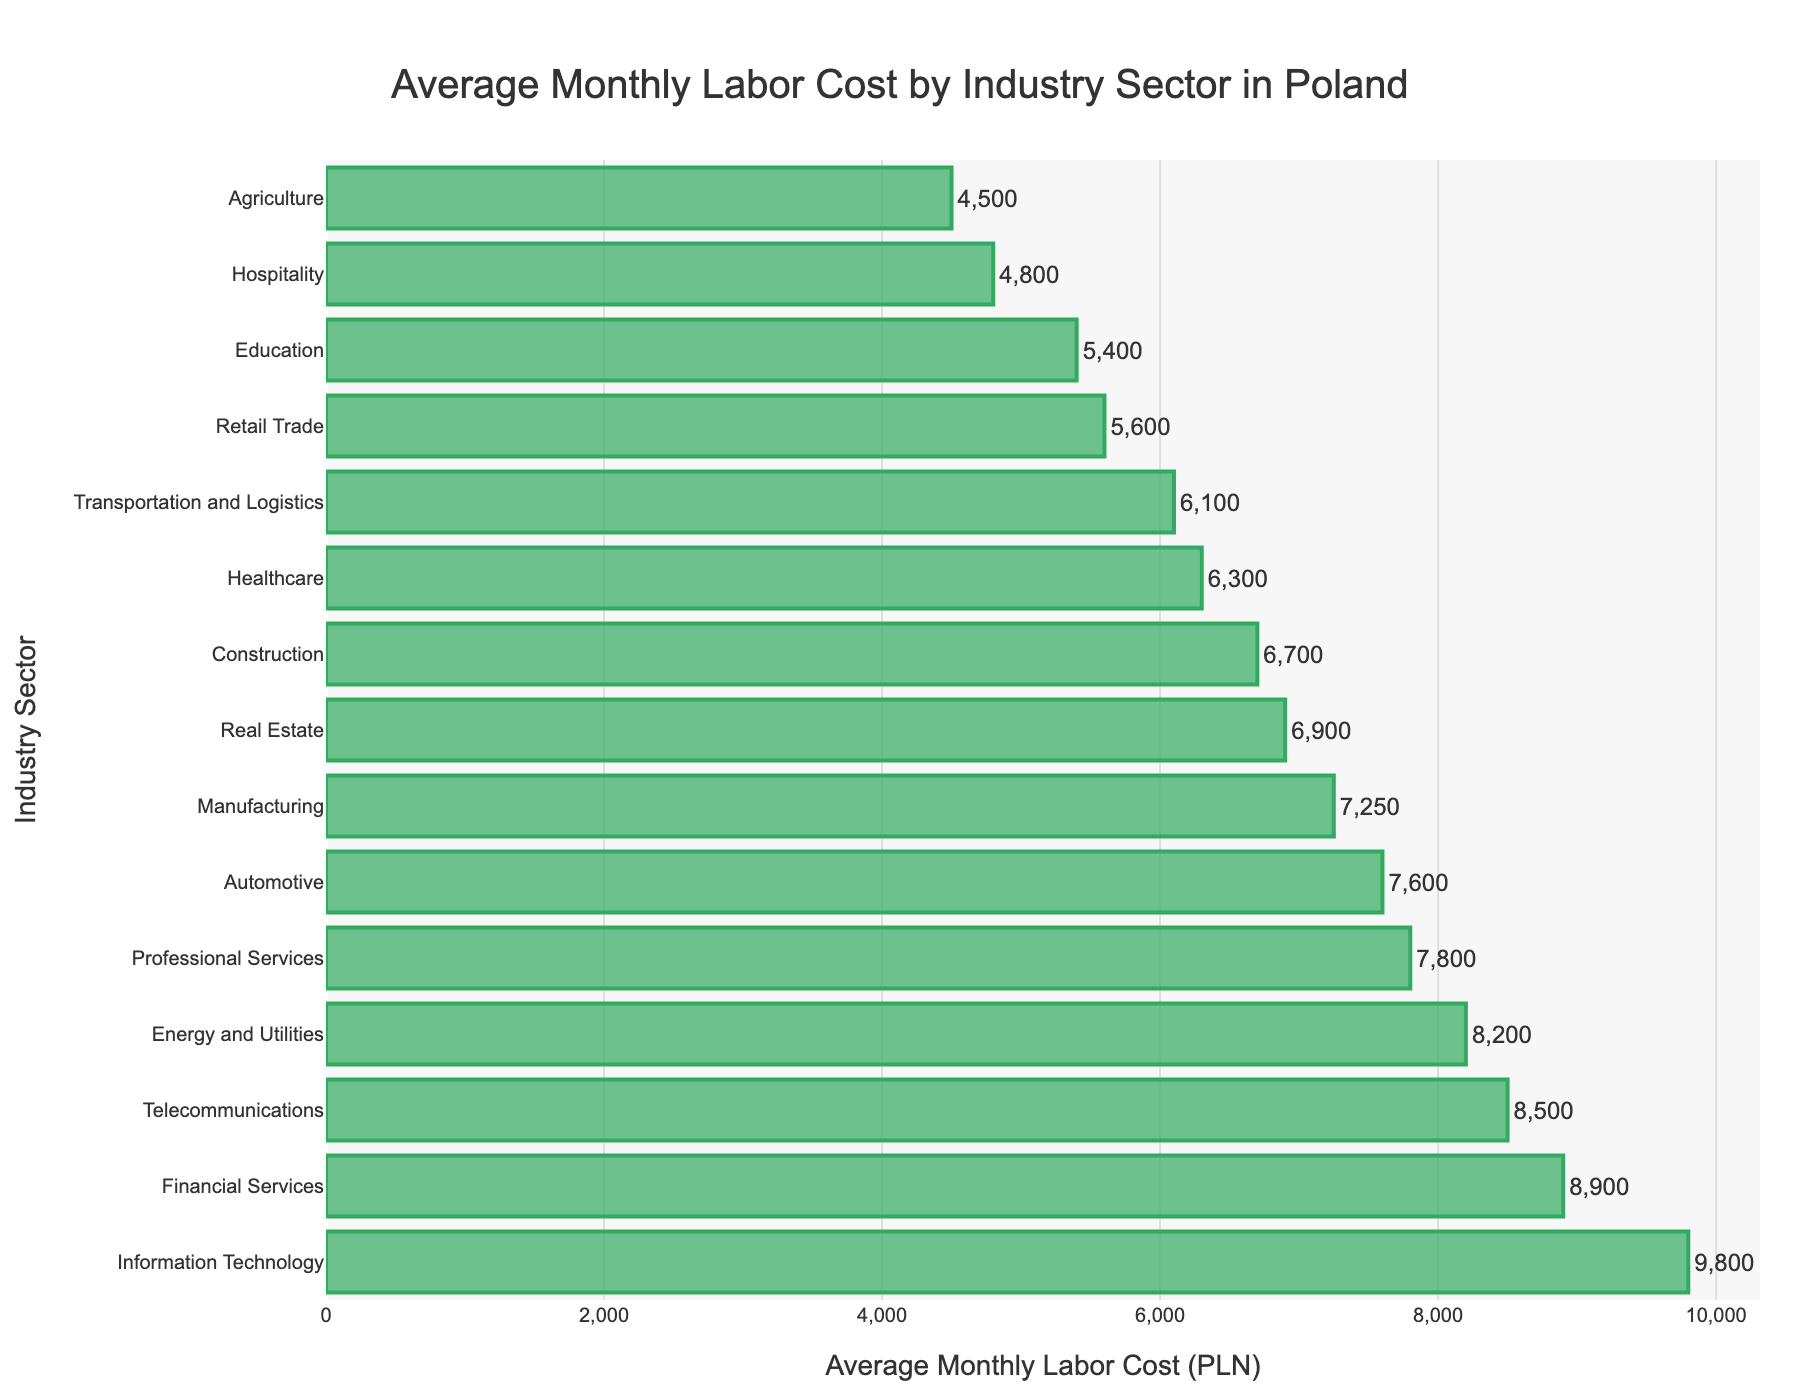Which industry sector has the highest average monthly labor cost? The bar chart shows the average monthly labor costs by industry sector sorted in descending order. The first bar from the top represents the sector with the highest cost, which is Information Technology.
Answer: Information Technology Which industry sector has the lowest average monthly labor cost? The bar chart shows the average monthly labor costs by industry sector sorted in descending order. The last bar represents the sector with the lowest cost, which is Agriculture.
Answer: Agriculture What is the difference in average monthly labor cost between the highest and lowest sectors? The highest average monthly labor cost is for Information Technology (9800 PLN), and the lowest is for Agriculture (4500 PLN). Subtracting the lowest from the highest: 9800 - 4500 = 5300 PLN.
Answer: 5300 PLN How do the average monthly labor costs of the Financial Services and Real Estate sectors compare? The bar chart shows that Financial Services have an average monthly labor cost of 8900 PLN, while Real Estate has 6900 PLN. Financial Services have a higher cost by 2000 PLN.
Answer: Financial Services are 2000 PLN higher than Real Estate Which industry sector has an average monthly labor cost closest to 7000 PLN? Looking at the bar chart, the sector with an average monthly labor cost closest to 7000 PLN is Real Estate, which has a cost of 6900 PLN.
Answer: Real Estate What is the combined average monthly labor cost of the Manufacturing and Healthcare sectors? The bar chart shows Manufacturing has a cost of 7250 PLN and Healthcare has a cost of 6300 PLN. Adding these together gives: 7250 + 6300 = 13550 PLN.
Answer: 13550 PLN How many industry sectors have an average monthly labor cost greater than 8000 PLN? From the bar chart, the sectors with labor costs greater than 8000 PLN are Information Technology (9800 PLN), Financial Services (8900 PLN), Telecommunications (8500 PLN), and Energy and Utilities (8200 PLN). Thus, there are 4 such sectors.
Answer: 4 sectors What's the average value of the top three industry sectors in terms of labor cost? The top three sectors by labor cost on the bar chart are Information Technology (9800 PLN), Financial Services (8900 PLN), and Telecommunications (8500 PLN). Their sum is 9800 + 8900 + 8500 = 27200 PLN. Dividing by 3 gives the average: 27200 / 3 ≈ 9067 PLN.
Answer: Approximately 9067 PLN Which sector has a lower average monthly labor cost, Education or Transportation and Logistics, and by how much? The bar chart shows Education with a labor cost of 5400 PLN and Transportation and Logistics with 6100 PLN. Education is lower by 6100 - 5400 = 700 PLN.
Answer: Education, by 700 PLN 